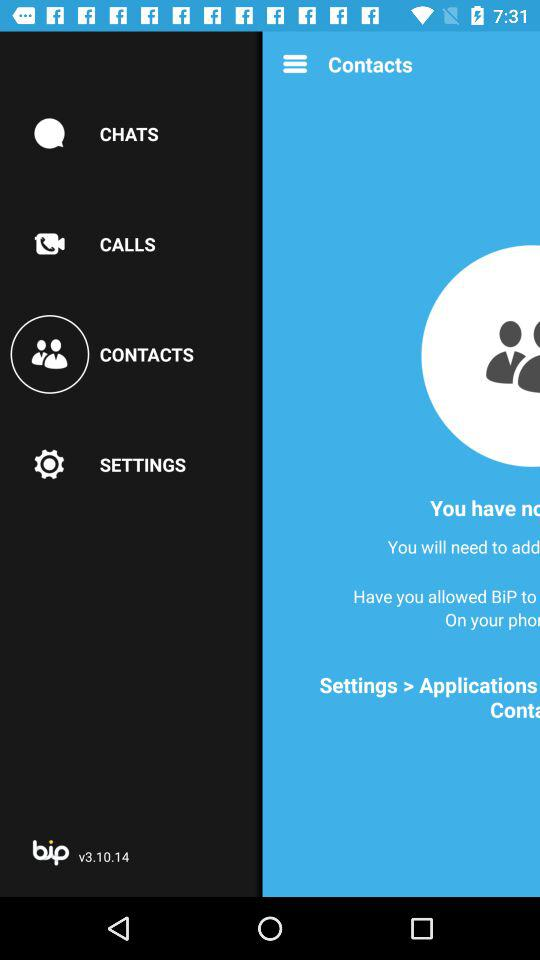Which version is used? The used version is v3.10.14. 